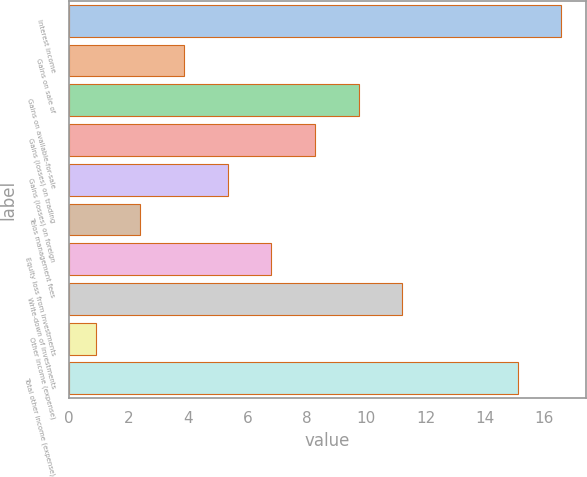<chart> <loc_0><loc_0><loc_500><loc_500><bar_chart><fcel>Interest income<fcel>Gains on sale of<fcel>Gains on available-for-sale<fcel>Gains (losses) on trading<fcel>Gains (losses) on foreign<fcel>Telos management fees<fcel>Equity loss from investments<fcel>Write-down of investments<fcel>Other income (expense)<fcel>Total other income (expense)<nl><fcel>16.57<fcel>3.87<fcel>9.75<fcel>8.28<fcel>5.34<fcel>2.4<fcel>6.81<fcel>11.22<fcel>0.9<fcel>15.1<nl></chart> 